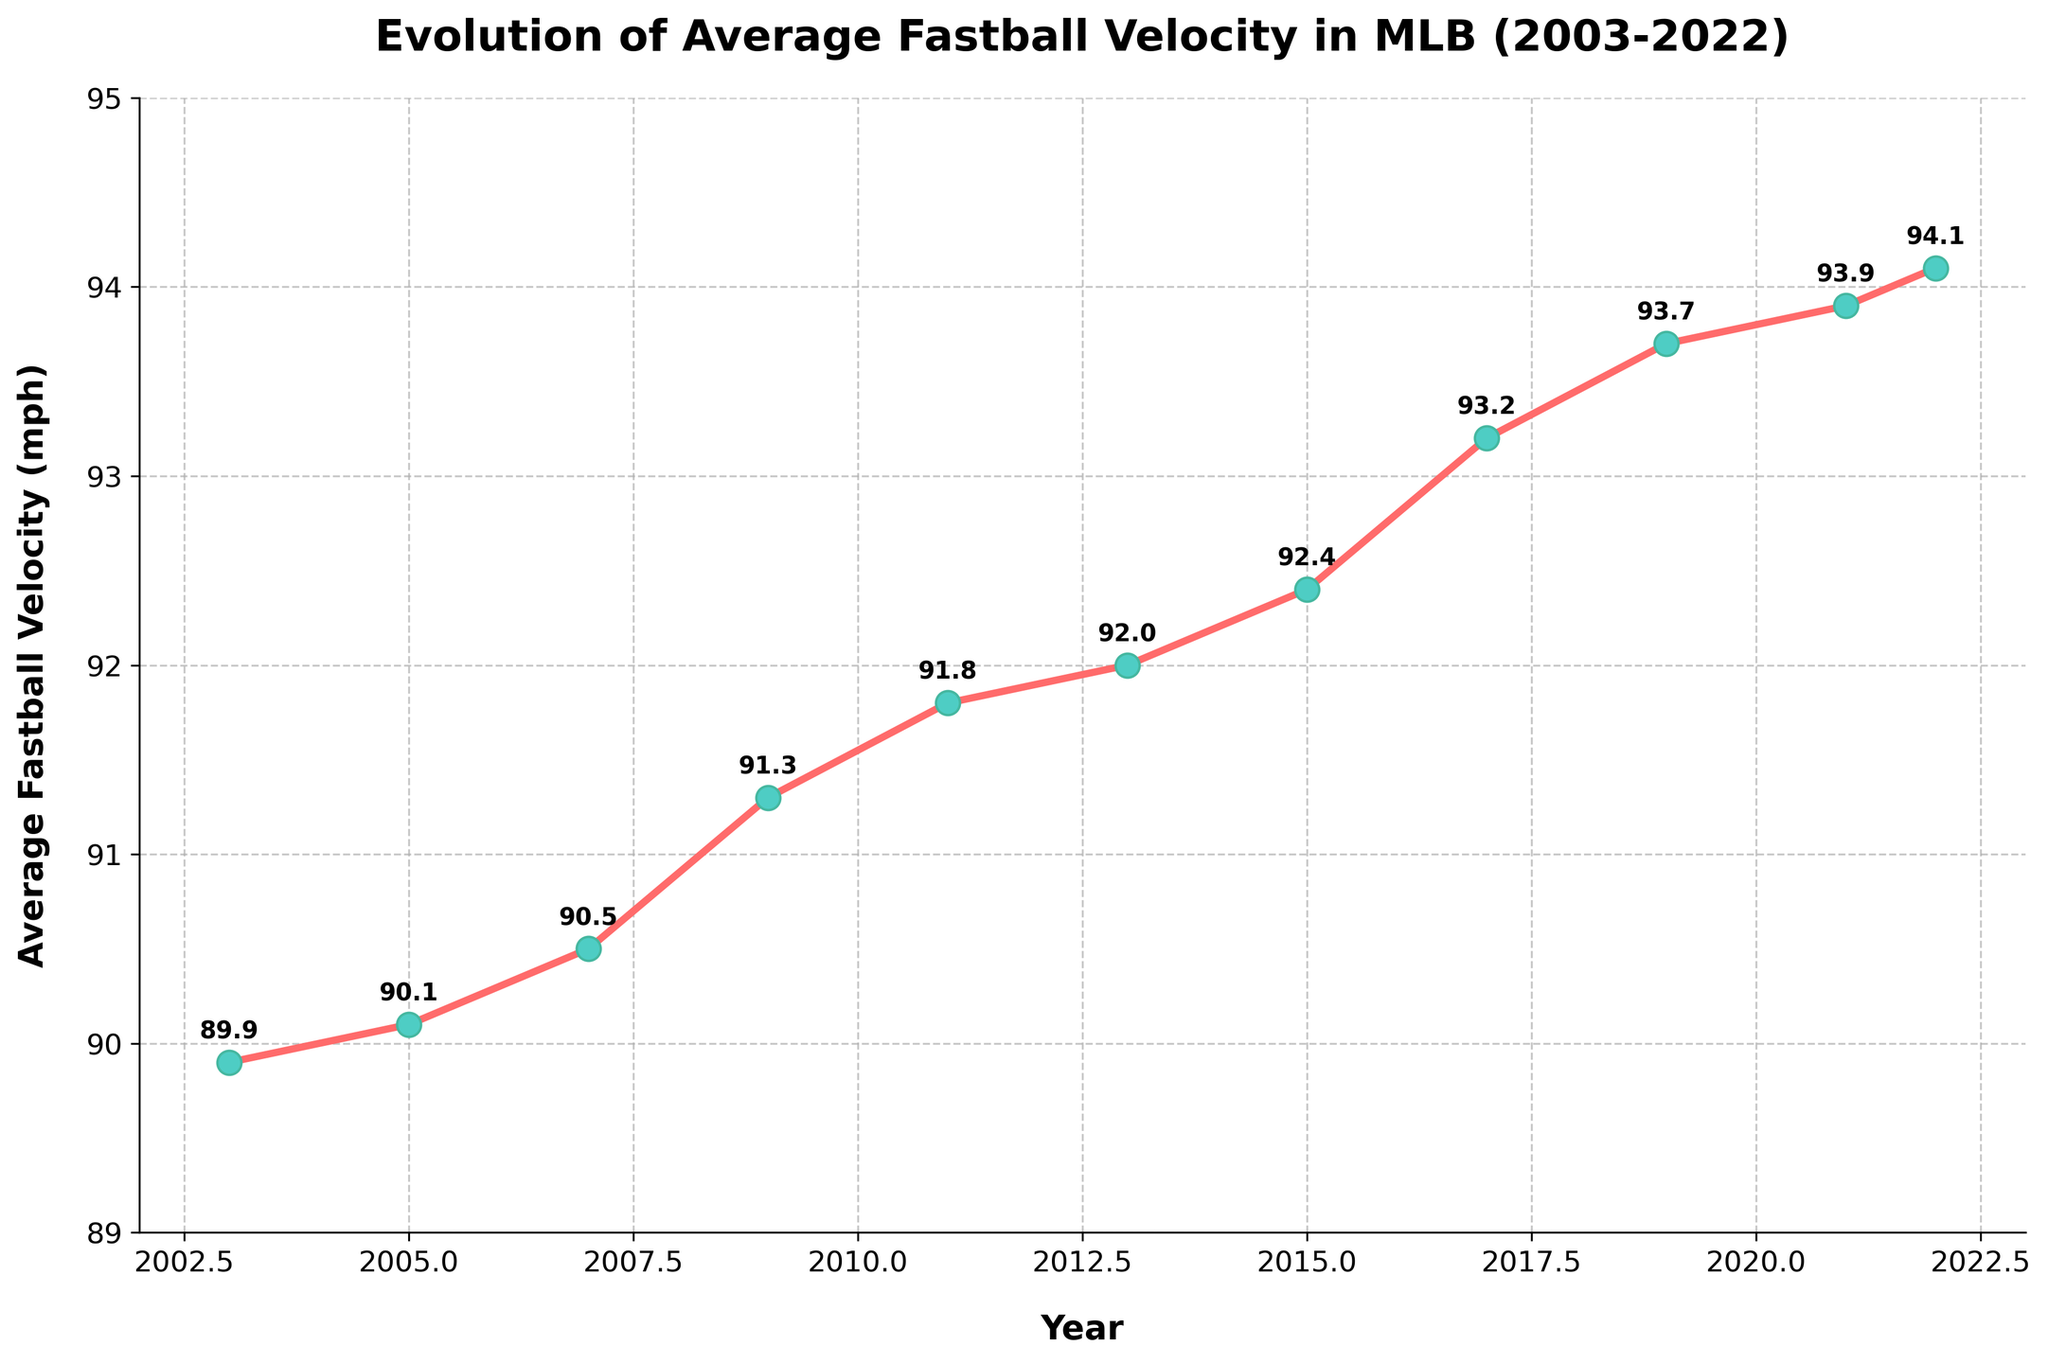What year had the highest average fastball velocity? To find the year with the highest average fastball velocity, look for the peak point on the line chart. The highest value is 94.1 mph in 2022.
Answer: 2022 What is the overall trend in average fastball velocity from 2003 to 2022? To determine the overall trend, observe the slope of the line connecting points from 2003 to 2022. The slope is upward, indicating an increasing trend.
Answer: Increasing How much did the average fastball velocity increase from 2003 to 2022? Subtract the average fastball velocity in 2003 (89.9 mph) from that in 2022 (94.1 mph): 94.1 - 89.9 = 4.2 mph.
Answer: 4.2 mph Between which consecutive years is the largest increase in average fastball velocity observed? Compare the differences between each consecutive year’s velocities. The largest increase is between 2015 (92.4 mph) and 2017 (93.2 mph): 93.2 - 92.4 = 0.8 mph.
Answer: 2015 to 2017 Which years have a documented average fastball velocity below 90 mph? Look for years where the fastball velocity is below 90 mph. The only year meeting this criterion is 2003 with 89.9 mph.
Answer: 2003 What was the average fastball velocity in 2015 compared to 2019? Retrieve the values for 2015 (92.4 mph) and 2019 (93.7 mph). 93.7 is greater than 92.4, so the average fastball velocity in 2019 was higher.
Answer: 2019 was higher In which year did the average fastball velocity first reach or exceed 91 mph? Search through the years chronologically until you find a velocity equal to or greater than 91 mph. It first occurs in 2009 with 91.3 mph.
Answer: 2009 How does the average fastball velocity change between 2017 and 2022? Compare the values of 2017 (93.2 mph) and 2022 (94.1 mph): 94.1 - 93.2 = 0.9 mph increase.
Answer: Increase of 0.9 mph When comparing 2005 and 2011, which year had a higher average fastball velocity and by how much? Retrieve the values for 2005 (90.1 mph) and 2011 (91.8 mph). Calculate the difference: 91.8 - 90.1 = 1.7 mph.
Answer: 2011 by 1.7 mph By what percentage did the average fastball velocity increase from 2003 to 2022? Use the formula [(94.1 - 89.9) / 89.9] * 100 = 4.2 / 89.9 * 100 ≈ 4.67%.
Answer: 4.67% 